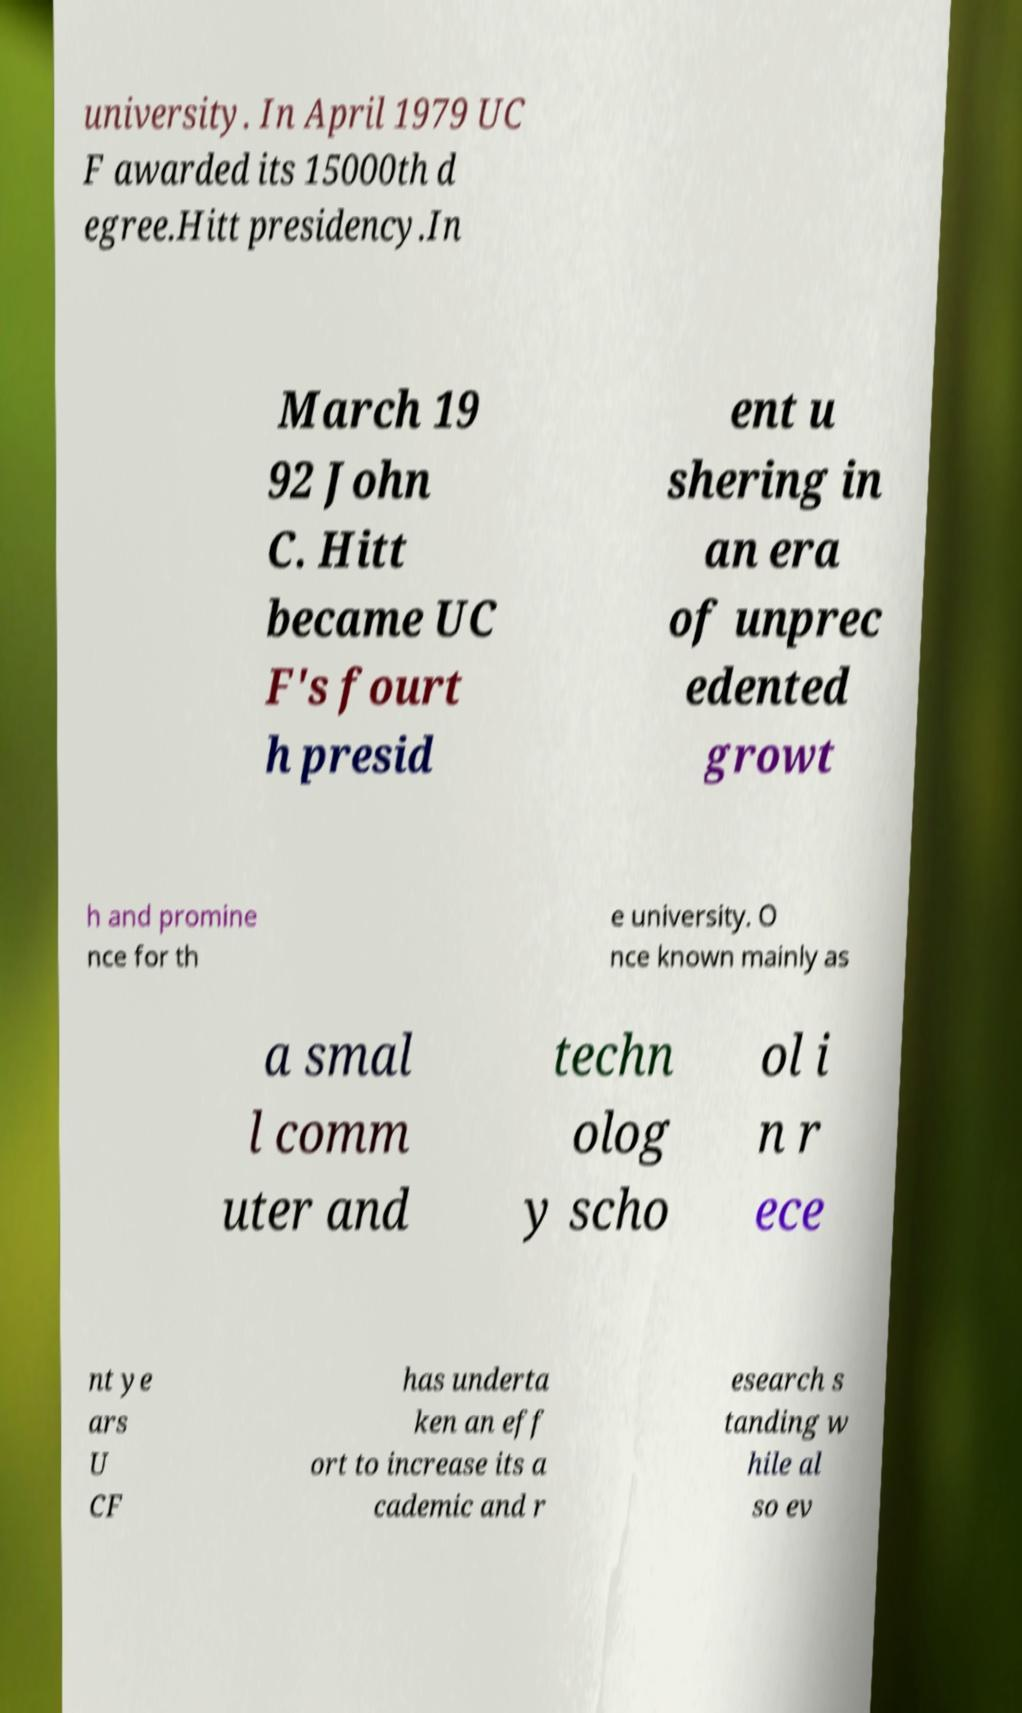Can you accurately transcribe the text from the provided image for me? university. In April 1979 UC F awarded its 15000th d egree.Hitt presidency.In March 19 92 John C. Hitt became UC F's fourt h presid ent u shering in an era of unprec edented growt h and promine nce for th e university. O nce known mainly as a smal l comm uter and techn olog y scho ol i n r ece nt ye ars U CF has underta ken an eff ort to increase its a cademic and r esearch s tanding w hile al so ev 